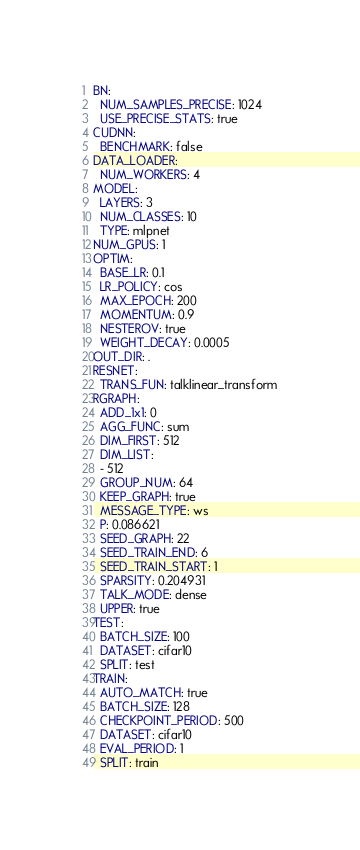Convert code to text. <code><loc_0><loc_0><loc_500><loc_500><_YAML_>BN:
  NUM_SAMPLES_PRECISE: 1024
  USE_PRECISE_STATS: true
CUDNN:
  BENCHMARK: false
DATA_LOADER:
  NUM_WORKERS: 4
MODEL:
  LAYERS: 3
  NUM_CLASSES: 10
  TYPE: mlpnet
NUM_GPUS: 1
OPTIM:
  BASE_LR: 0.1
  LR_POLICY: cos
  MAX_EPOCH: 200
  MOMENTUM: 0.9
  NESTEROV: true
  WEIGHT_DECAY: 0.0005
OUT_DIR: .
RESNET:
  TRANS_FUN: talklinear_transform
RGRAPH:
  ADD_1x1: 0
  AGG_FUNC: sum
  DIM_FIRST: 512
  DIM_LIST:
  - 512
  GROUP_NUM: 64
  KEEP_GRAPH: true
  MESSAGE_TYPE: ws
  P: 0.086621
  SEED_GRAPH: 22
  SEED_TRAIN_END: 6
  SEED_TRAIN_START: 1
  SPARSITY: 0.204931
  TALK_MODE: dense
  UPPER: true
TEST:
  BATCH_SIZE: 100
  DATASET: cifar10
  SPLIT: test
TRAIN:
  AUTO_MATCH: true
  BATCH_SIZE: 128
  CHECKPOINT_PERIOD: 500
  DATASET: cifar10
  EVAL_PERIOD: 1
  SPLIT: train
</code> 